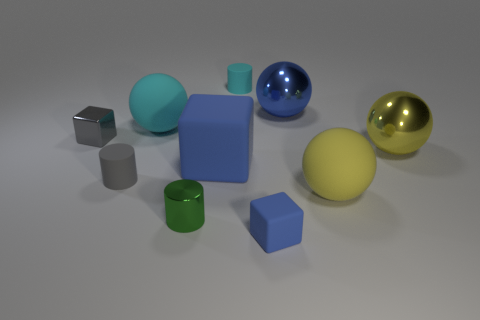What number of small gray objects are behind the blue cube that is left of the tiny blue matte thing?
Make the answer very short. 1. Does the rubber cube that is right of the cyan rubber cylinder have the same size as the green metallic cylinder?
Give a very brief answer. Yes. How many cyan things are the same shape as the green object?
Make the answer very short. 1. The tiny green thing is what shape?
Provide a succinct answer. Cylinder. Is the number of tiny things that are right of the large blue sphere the same as the number of tiny yellow rubber objects?
Keep it short and to the point. Yes. Do the blue block in front of the gray cylinder and the big cyan thing have the same material?
Your response must be concise. Yes. Are there fewer tiny blue rubber blocks left of the metal cylinder than small gray cubes?
Ensure brevity in your answer.  Yes. How many shiny things are brown things or small blue things?
Your response must be concise. 0. Do the big matte cube and the tiny rubber block have the same color?
Provide a short and direct response. Yes. Is there any other thing that has the same color as the shiny cylinder?
Offer a very short reply. No. 